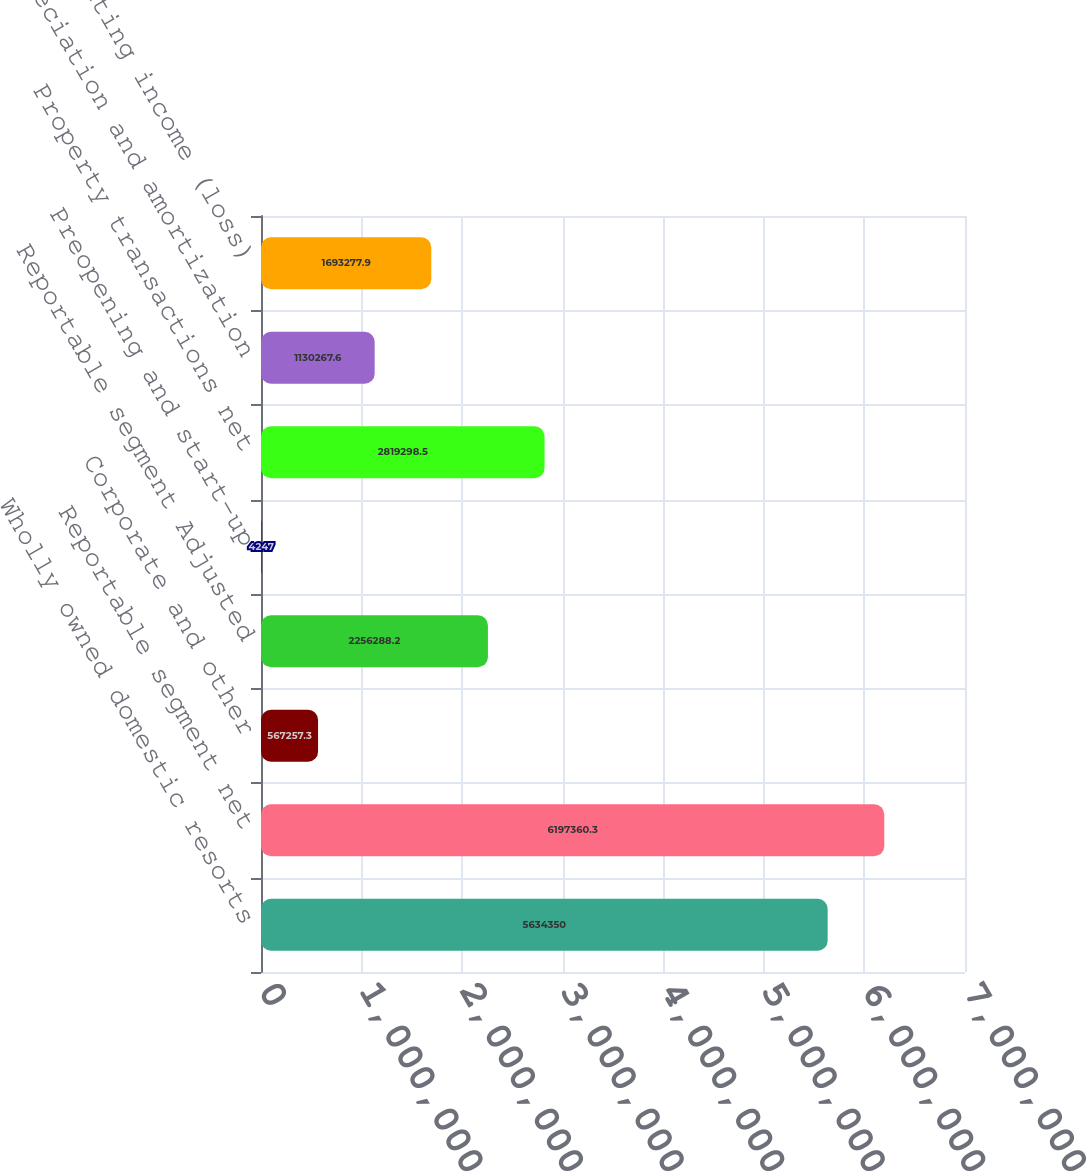Convert chart to OTSL. <chart><loc_0><loc_0><loc_500><loc_500><bar_chart><fcel>Wholly owned domestic resorts<fcel>Reportable segment net<fcel>Corporate and other<fcel>Reportable segment Adjusted<fcel>Preopening and start-up<fcel>Property transactions net<fcel>Depreciation and amortization<fcel>Operating income (loss)<nl><fcel>5.63435e+06<fcel>6.19736e+06<fcel>567257<fcel>2.25629e+06<fcel>4247<fcel>2.8193e+06<fcel>1.13027e+06<fcel>1.69328e+06<nl></chart> 